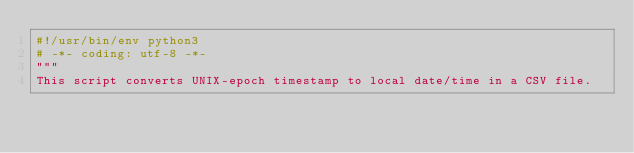<code> <loc_0><loc_0><loc_500><loc_500><_Python_>#!/usr/bin/env python3
# -*- coding: utf-8 -*-
"""
This script converts UNIX-epoch timestamp to local date/time in a CSV file.</code> 